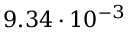<formula> <loc_0><loc_0><loc_500><loc_500>9 . 3 4 \cdot 1 0 ^ { - 3 }</formula> 